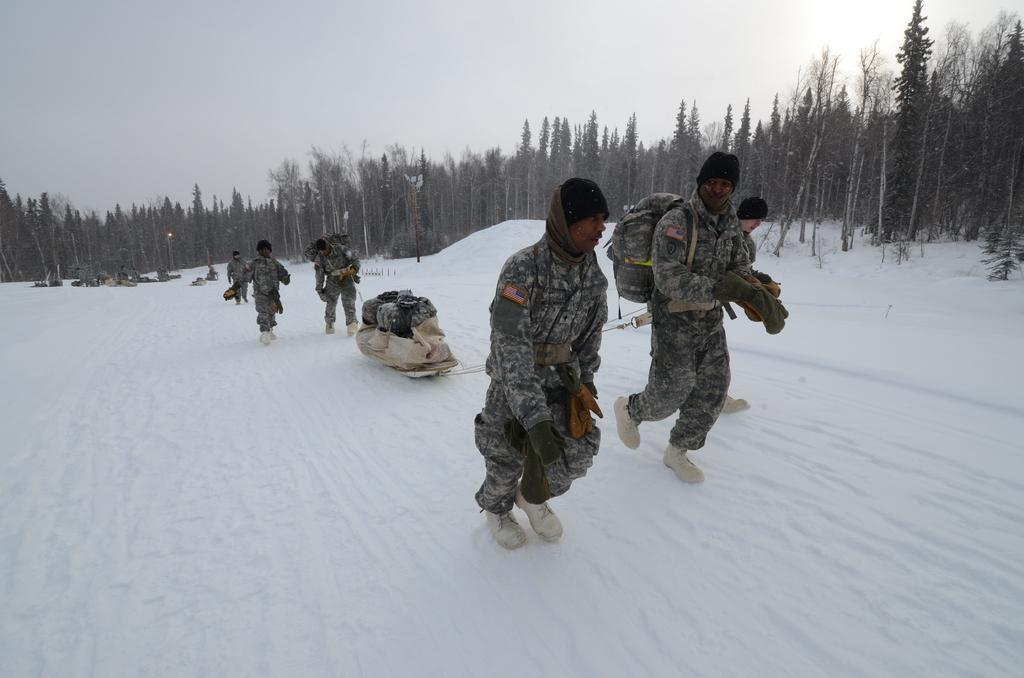What type of people can be seen in the image? There are army people in the image. What are the army people doing in the image? The army people are walking on the snow. What type of natural environment is visible in the image? There are trees in the image, and they are fully covered with snow. What type of waste can be seen in the image? There is no waste present in the image. How does the digestion of the trees affect their appearance in the image? The trees in the image are fully covered with snow, and digestion is not relevant to their appearance. 